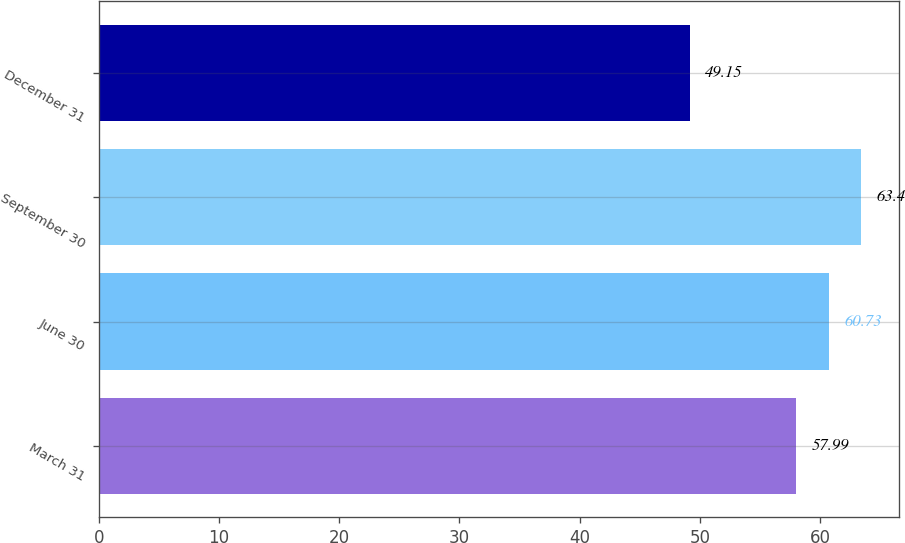Convert chart. <chart><loc_0><loc_0><loc_500><loc_500><bar_chart><fcel>March 31<fcel>June 30<fcel>September 30<fcel>December 31<nl><fcel>57.99<fcel>60.73<fcel>63.4<fcel>49.15<nl></chart> 